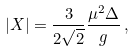<formula> <loc_0><loc_0><loc_500><loc_500>| X | = { \frac { 3 } { 2 \sqrt { 2 } } } { \frac { \mu ^ { 2 } \Delta } { g } } \, ,</formula> 